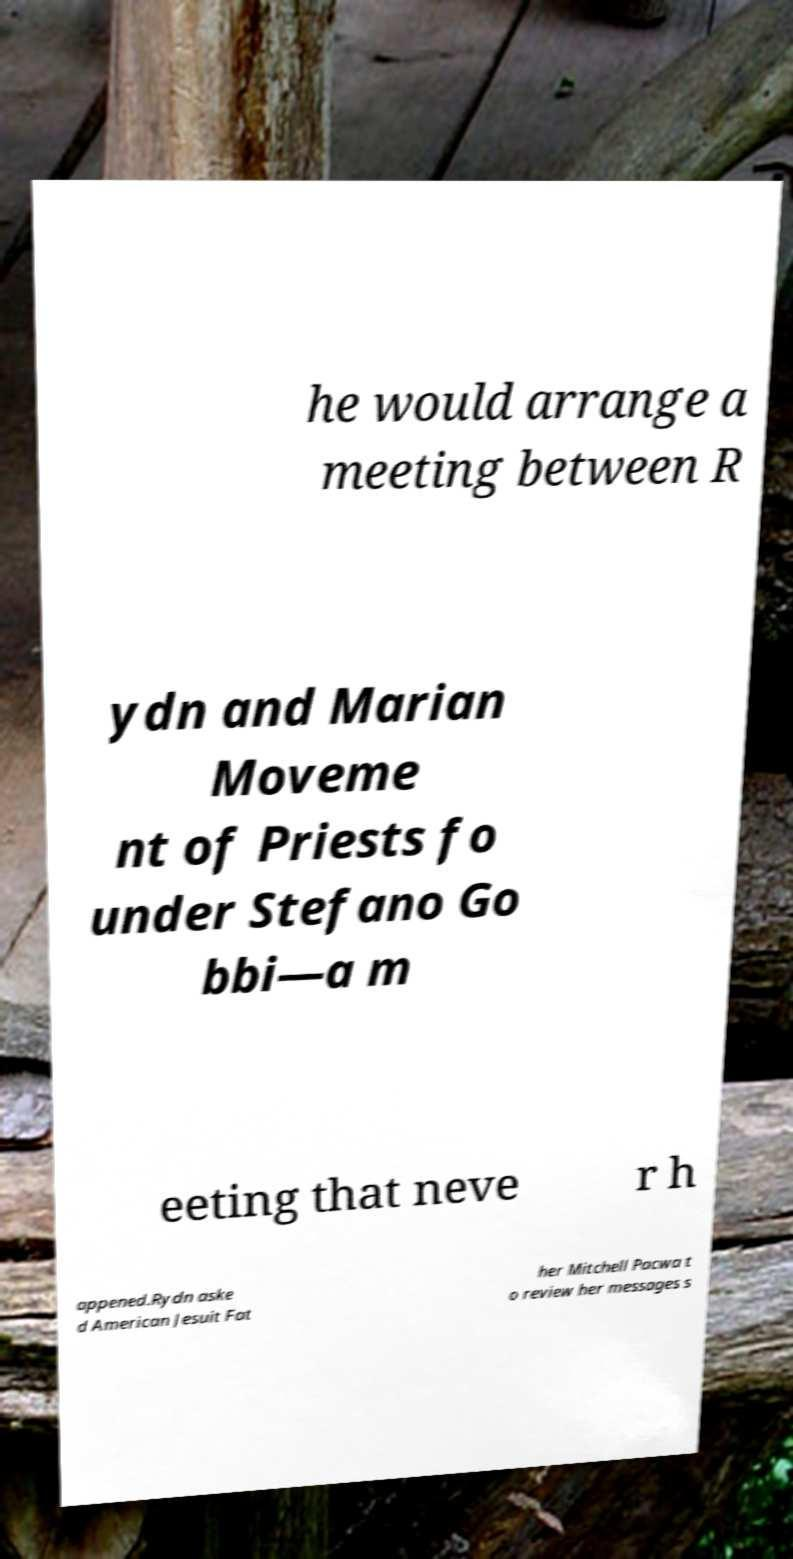What messages or text are displayed in this image? I need them in a readable, typed format. he would arrange a meeting between R ydn and Marian Moveme nt of Priests fo under Stefano Go bbi—a m eeting that neve r h appened.Rydn aske d American Jesuit Fat her Mitchell Pacwa t o review her messages s 